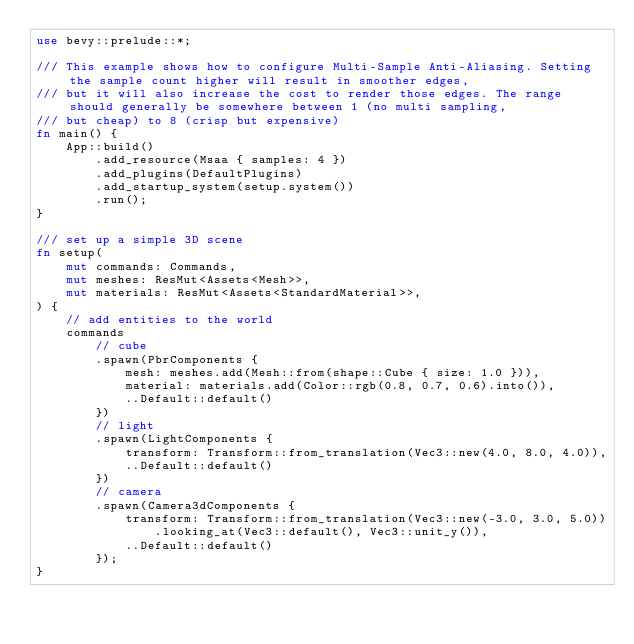Convert code to text. <code><loc_0><loc_0><loc_500><loc_500><_Rust_>use bevy::prelude::*;

/// This example shows how to configure Multi-Sample Anti-Aliasing. Setting the sample count higher will result in smoother edges,
/// but it will also increase the cost to render those edges. The range should generally be somewhere between 1 (no multi sampling,
/// but cheap) to 8 (crisp but expensive)
fn main() {
    App::build()
        .add_resource(Msaa { samples: 4 })
        .add_plugins(DefaultPlugins)
        .add_startup_system(setup.system())
        .run();
}

/// set up a simple 3D scene
fn setup(
    mut commands: Commands,
    mut meshes: ResMut<Assets<Mesh>>,
    mut materials: ResMut<Assets<StandardMaterial>>,
) {
    // add entities to the world
    commands
        // cube
        .spawn(PbrComponents {
            mesh: meshes.add(Mesh::from(shape::Cube { size: 1.0 })),
            material: materials.add(Color::rgb(0.8, 0.7, 0.6).into()),
            ..Default::default()
        })
        // light
        .spawn(LightComponents {
            transform: Transform::from_translation(Vec3::new(4.0, 8.0, 4.0)),
            ..Default::default()
        })
        // camera
        .spawn(Camera3dComponents {
            transform: Transform::from_translation(Vec3::new(-3.0, 3.0, 5.0))
                .looking_at(Vec3::default(), Vec3::unit_y()),
            ..Default::default()
        });
}
</code> 